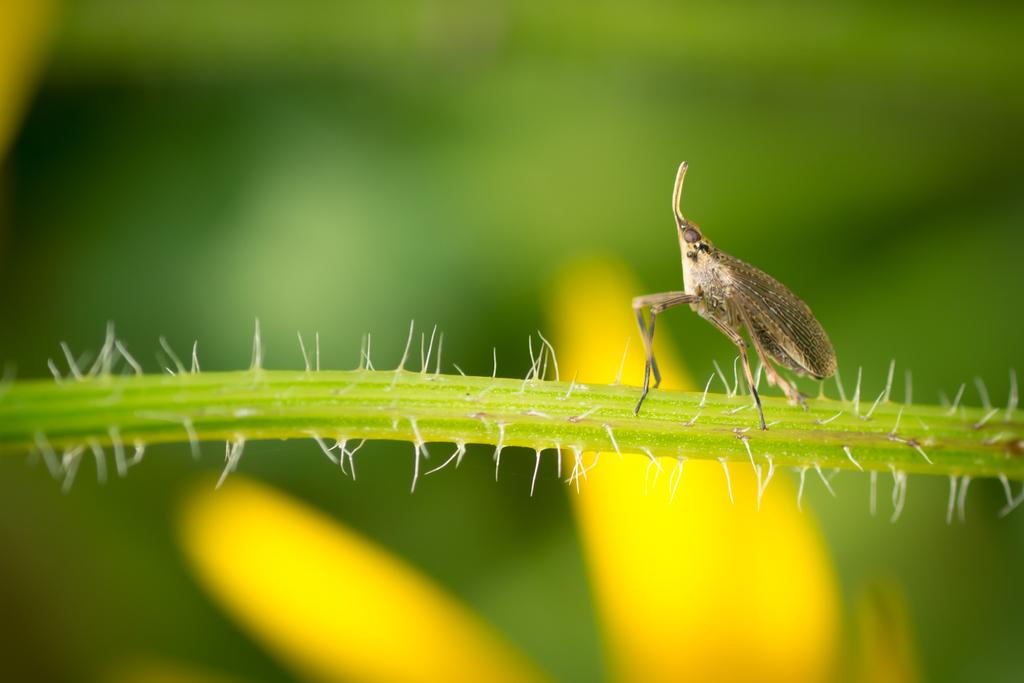What type of creature can be seen in the picture? There is an insect in the picture. Where is the insect located? The insect is on a stem or branch. What other features can be seen in the image? There are thorns in the picture. How would you describe the background of the image? The background of the image is blurred. How many light bulbs can be seen in the picture? There are no light bulbs present in the image. 